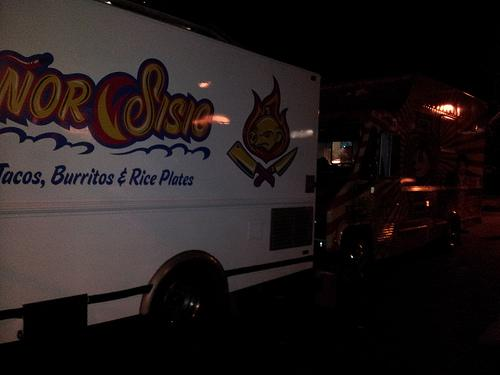What can you observe about the wheel and rim on the trailer? The wheel on the trailer has a black rim, and the rim itself is approximately 39 units in width and height. Provide a description of the food truck's windshield. The front windshield of the food truck is 26 units wide and 26 units high. What kind of vehicle is the main focus of the image? The main focus of the image is a food truck parked on the street. What are the two types of knives included in the business logo on the side of the food truck? The business logo features a meat cleaver and a kitchen knife. Describe the design present on the side of the food truck. The design on the side of the food truck includes a business logo with knives, red and yellow flames, and blue lettering on a white background. What can you say about the reflections seen on the vehicles in the image? Light reflections can be seen on both the white trailer and the food truck, with the reflections on the food truck measuring 100 units in width and height. Identify the primary object of the image and describe its main features. The primary object is a white food truck with blue lettering, red and yellow flames, a business logo featuring knives, and a black stripe on the bottom. Explain what objects are visible in the image's background. In the background, there are cars parked behind the food truck and a large white trailer parked on the street. How many objects with blue lettering on a white background can be seen in the image? There are 9 objects with blue lettering on a white background. List the colors and elements of the food truck's decoration. The food truck's decoration includes blue lettering, red and yellow flames, a business logo with knives, and a black stripe on the bottom. Check out the street sign on the sidewalk next to the parked cars, indicating the food truck's parking zone. There is no mention of a street sign in the image, making this instruction misleading as it suggests the presence of a non-existent object. Isn't it interesting to see the dog sleeping inside the large white truck, with its head comfortably resting on the dashboard? There is no mention of a dog or any other animal in the image, which makes the instruction misleading as it asks the reader to notice a non-existent element. Observe the graffiti art on the side of the food truck, adding an interesting visual touch to the overall composition of the image. None of the image information mentions graffiti or any form of art on the food truck. This instruction is misleading as it implies the existence of a non-existent element in the image. Look for the young woman standing by the white trailer, proudly showing her company's logo on her t-shirt. None of the image information contains any mention of a person, particularly a young woman, making this instruction misleading. Can you spot the green bicycle leaning against the food truck? It seems to be parked right next to it. There is no mention of a green bicycle in the image, therefore it is misleading to suggest that it exists within the image. Notice the flock of birds flying over the food truck, creating a dynamic scene in the sky above it. No birds or any other flying elements are mentioned in the image, therefore, a flock of birds is a non-existent object in the image and the instruction is misleading. 